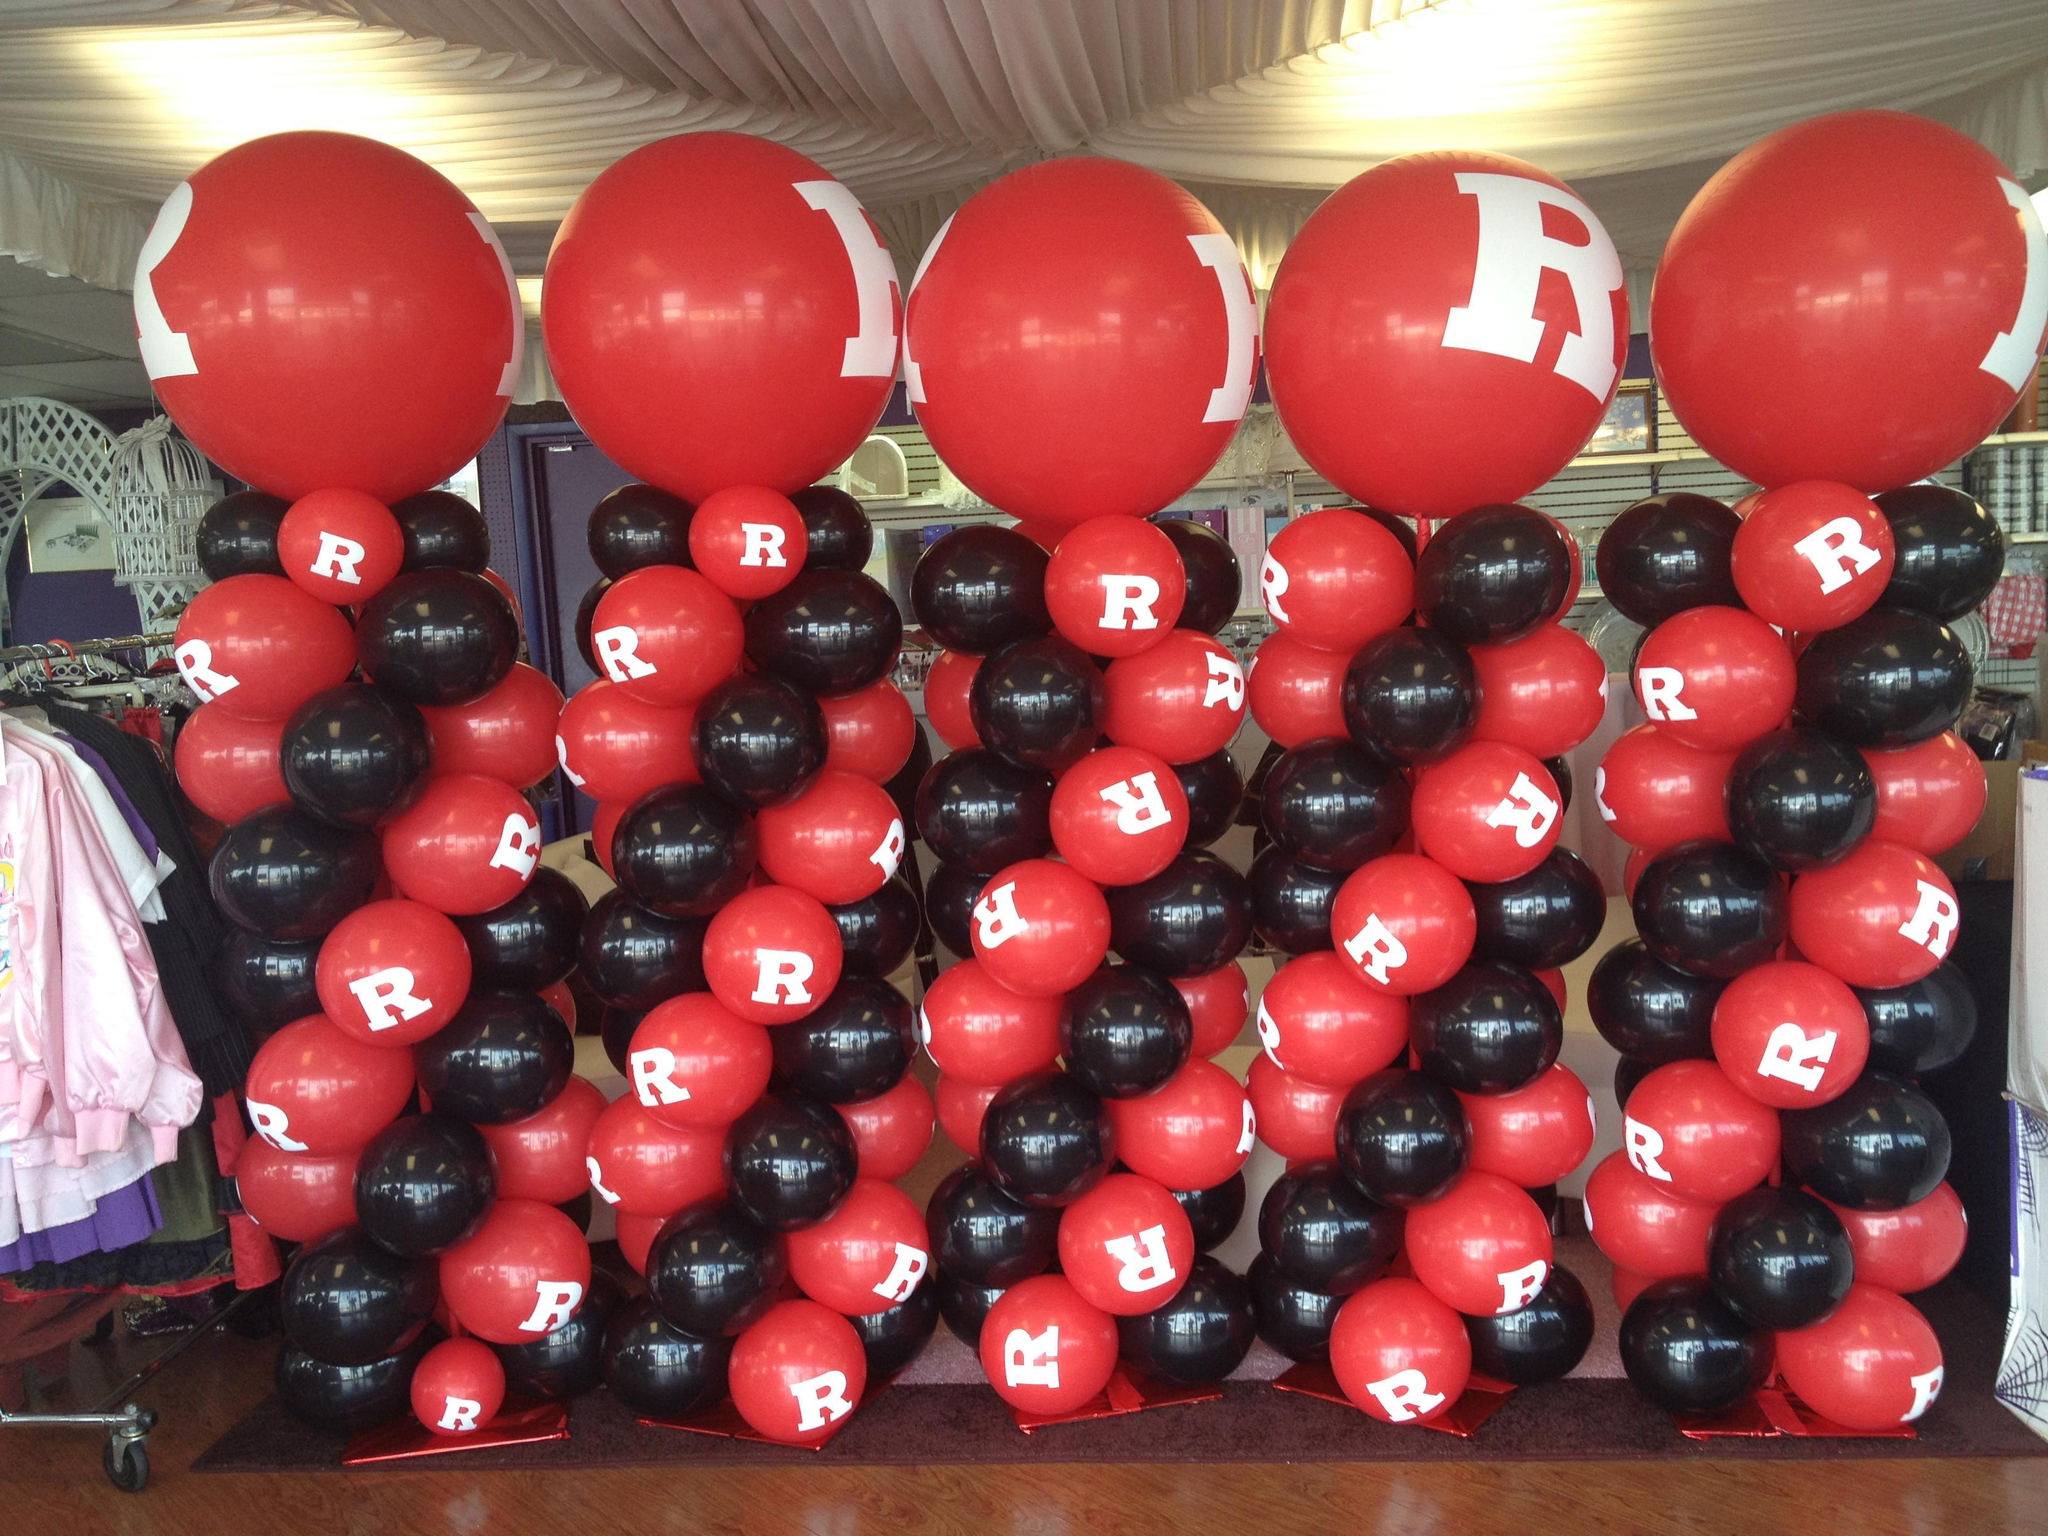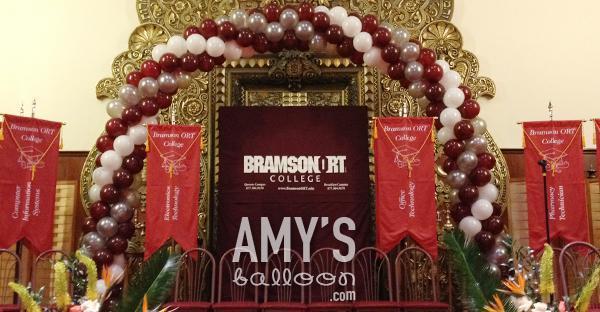The first image is the image on the left, the second image is the image on the right. Given the left and right images, does the statement "An image shows a balloon arch that forms a semi-circle and includes white and reddish balloons." hold true? Answer yes or no. Yes. The first image is the image on the left, the second image is the image on the right. Examine the images to the left and right. Is the description "In at least one image there is a balloon arch that is the same thickness all the way through with at least three rows of balloons.." accurate? Answer yes or no. Yes. 